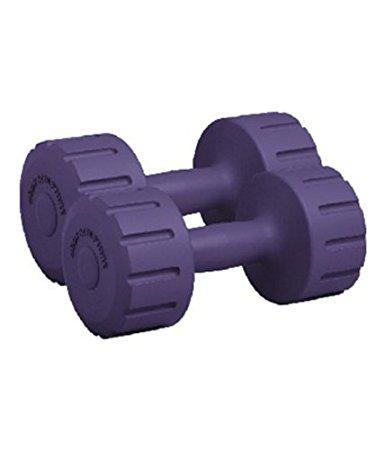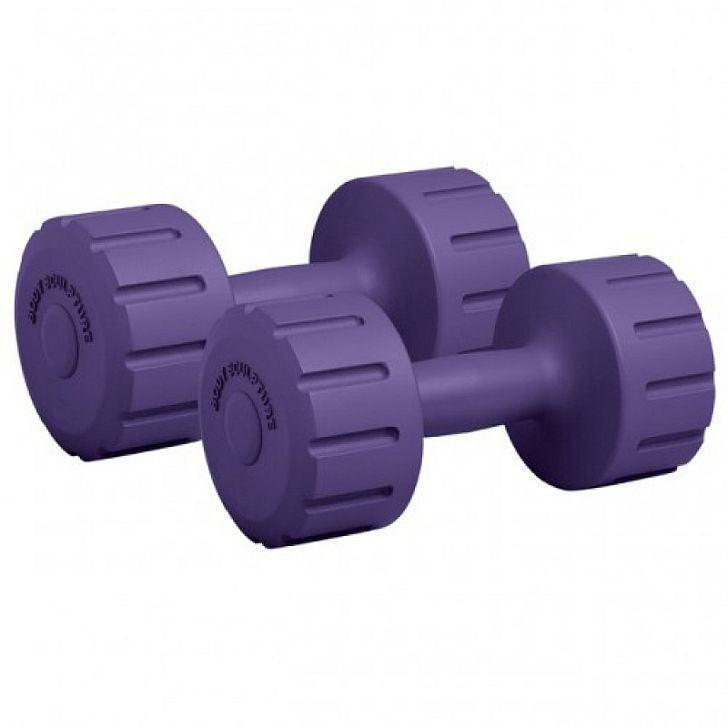The first image is the image on the left, the second image is the image on the right. Evaluate the accuracy of this statement regarding the images: "The pair of dumbells in the left image is the same color as the pair of dumbells in the right image.". Is it true? Answer yes or no. Yes. The first image is the image on the left, the second image is the image on the right. Analyze the images presented: Is the assertion "Each image shows two dumbbells, and right and left images show the same color weights." valid? Answer yes or no. Yes. 